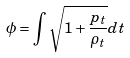<formula> <loc_0><loc_0><loc_500><loc_500>\phi = \int \sqrt { 1 + \frac { p _ { t } } { \rho _ { t } } } d t</formula> 